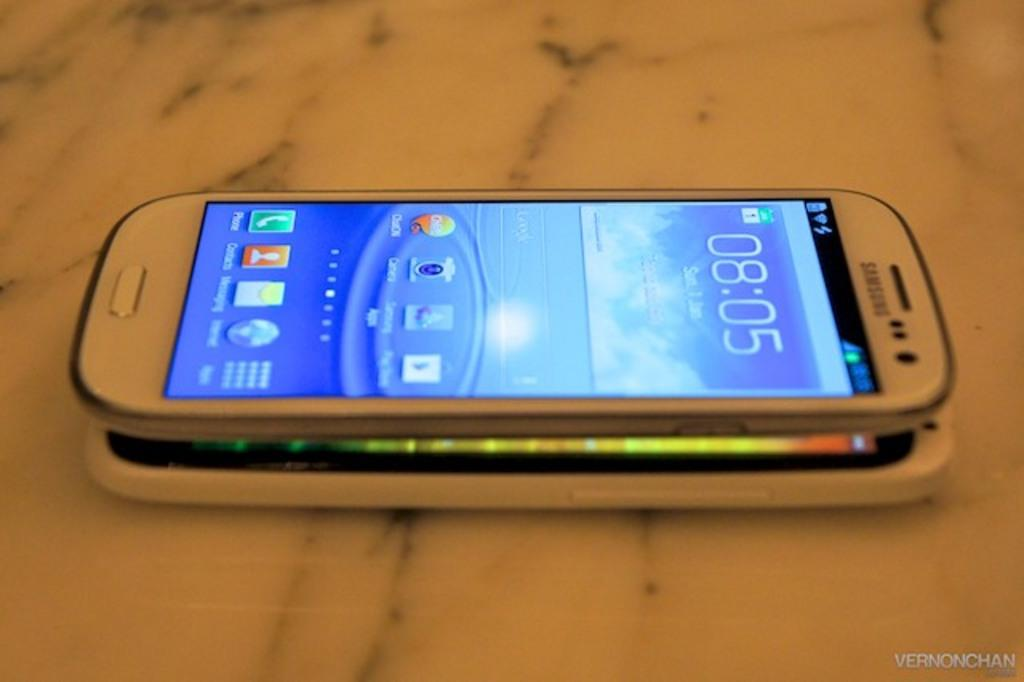<image>
Render a clear and concise summary of the photo. Two smart phones on top of each other and it says Vernonchan in the corner. 